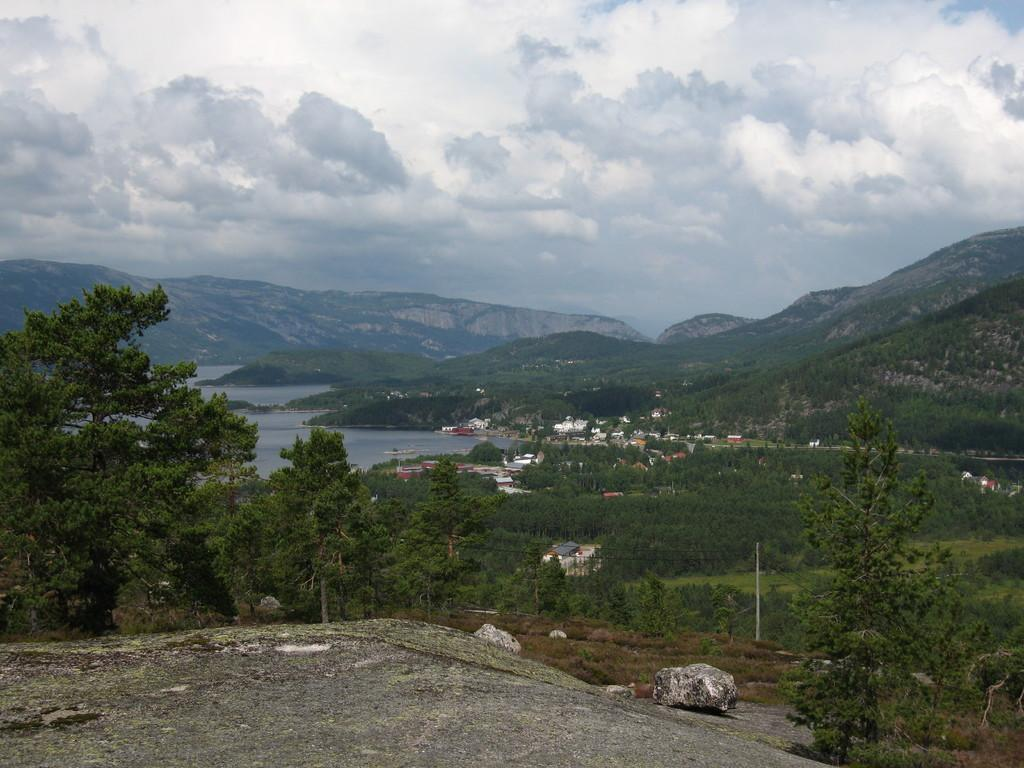What type of natural elements can be seen in the image? There are trees and hills visible in the image. What type of man-made structures can be seen in the image? There are buildings in the image. What is the condition of the sky in the image? The sky is cloudy in the image. What other natural element can be seen in the image? There is water visible in the image. What additional object can be seen in the image? There is a rock in the image. Can you tell me where the brother is skating in the image? There is no brother or skating activity present in the image. What is the brother carrying in his pocket in the image? There is no brother or pocket visible in the image. 